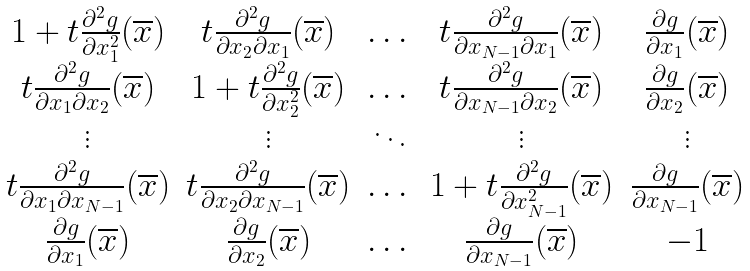Convert formula to latex. <formula><loc_0><loc_0><loc_500><loc_500>\begin{matrix} 1 + t \frac { \partial ^ { 2 } g } { \partial x _ { 1 } ^ { 2 } } ( \overline { x } ) & t \frac { \partial ^ { 2 } g } { \partial x _ { 2 } \partial x _ { 1 } } ( \overline { x } ) & \dots & t \frac { \partial ^ { 2 } g } { \partial x _ { N - 1 } \partial x _ { 1 } } ( \overline { x } ) & \frac { \partial g } { \partial x _ { 1 } } ( \overline { x } ) \\ t \frac { \partial ^ { 2 } g } { \partial x _ { 1 } \partial x _ { 2 } } ( \overline { x } ) & 1 + t \frac { \partial ^ { 2 } g } { \partial x _ { 2 } ^ { 2 } } ( \overline { x } ) & \dots & t \frac { \partial ^ { 2 } g } { \partial x _ { N - 1 } \partial x _ { 2 } } ( \overline { x } ) & \frac { \partial g } { \partial x _ { 2 } } ( \overline { x } ) \\ \vdots & \vdots & \ddots & \vdots & \vdots \\ t \frac { \partial ^ { 2 } g } { \partial x _ { 1 } \partial x _ { N - 1 } } ( \overline { x } ) & t \frac { \partial ^ { 2 } g } { \partial x _ { 2 } \partial x _ { N - 1 } } ( \overline { x } ) & \dots & 1 + t \frac { \partial ^ { 2 } g } { \partial x _ { N - 1 } ^ { 2 } } ( \overline { x } ) & \frac { \partial g } { \partial x _ { N - 1 } } ( \overline { x } ) \\ \frac { \partial g } { \partial x _ { 1 } } ( \overline { x } ) & \frac { \partial g } { \partial x _ { 2 } } ( \overline { x } ) & \dots & \frac { \partial g } { \partial x _ { N - 1 } } ( \overline { x } ) & - 1 \end{matrix}</formula> 